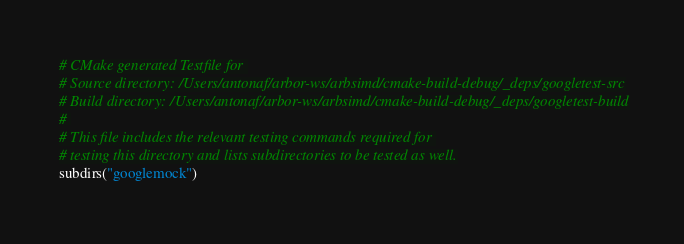Convert code to text. <code><loc_0><loc_0><loc_500><loc_500><_CMake_># CMake generated Testfile for 
# Source directory: /Users/antonaf/arbor-ws/arbsimd/cmake-build-debug/_deps/googletest-src
# Build directory: /Users/antonaf/arbor-ws/arbsimd/cmake-build-debug/_deps/googletest-build
# 
# This file includes the relevant testing commands required for 
# testing this directory and lists subdirectories to be tested as well.
subdirs("googlemock")
</code> 